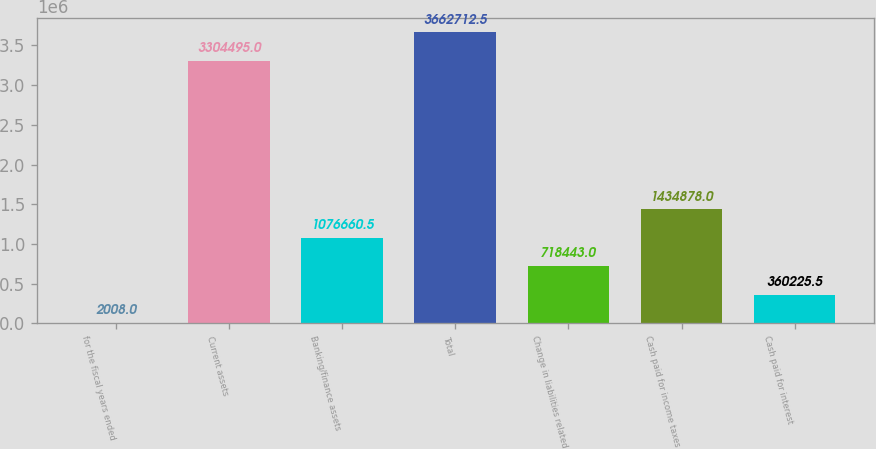<chart> <loc_0><loc_0><loc_500><loc_500><bar_chart><fcel>for the fiscal years ended<fcel>Current assets<fcel>Banking/finance assets<fcel>Total<fcel>Change in liabilities related<fcel>Cash paid for income taxes<fcel>Cash paid for interest<nl><fcel>2008<fcel>3.3045e+06<fcel>1.07666e+06<fcel>3.66271e+06<fcel>718443<fcel>1.43488e+06<fcel>360226<nl></chart> 